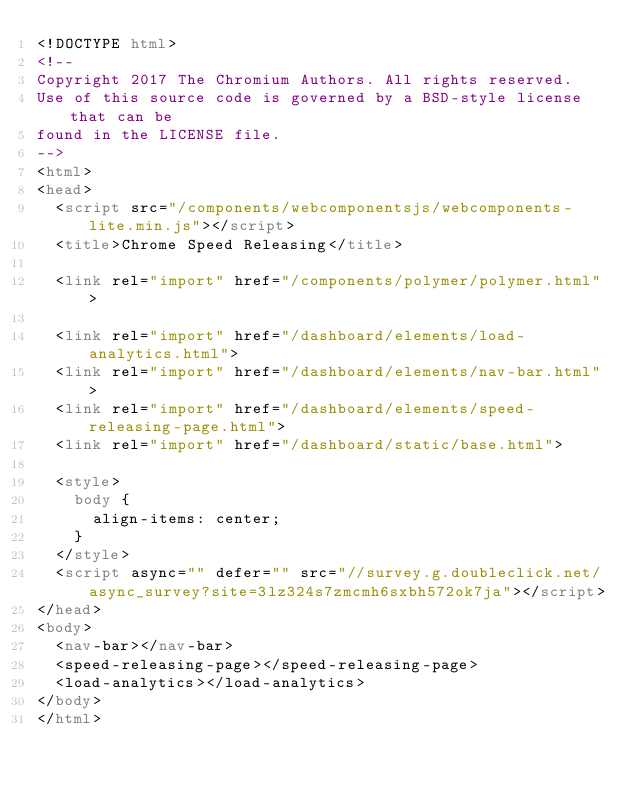Convert code to text. <code><loc_0><loc_0><loc_500><loc_500><_HTML_><!DOCTYPE html>
<!--
Copyright 2017 The Chromium Authors. All rights reserved.
Use of this source code is governed by a BSD-style license that can be
found in the LICENSE file.
-->
<html>
<head>
  <script src="/components/webcomponentsjs/webcomponents-lite.min.js"></script>
  <title>Chrome Speed Releasing</title>

  <link rel="import" href="/components/polymer/polymer.html">

  <link rel="import" href="/dashboard/elements/load-analytics.html">
  <link rel="import" href="/dashboard/elements/nav-bar.html">
  <link rel="import" href="/dashboard/elements/speed-releasing-page.html">
  <link rel="import" href="/dashboard/static/base.html">

  <style>
    body {
      align-items: center;
    }
  </style>
  <script async="" defer="" src="//survey.g.doubleclick.net/async_survey?site=3lz324s7zmcmh6sxbh572ok7ja"></script>
</head>
<body>
  <nav-bar></nav-bar>
  <speed-releasing-page></speed-releasing-page>
  <load-analytics></load-analytics>
</body>
</html>
</code> 